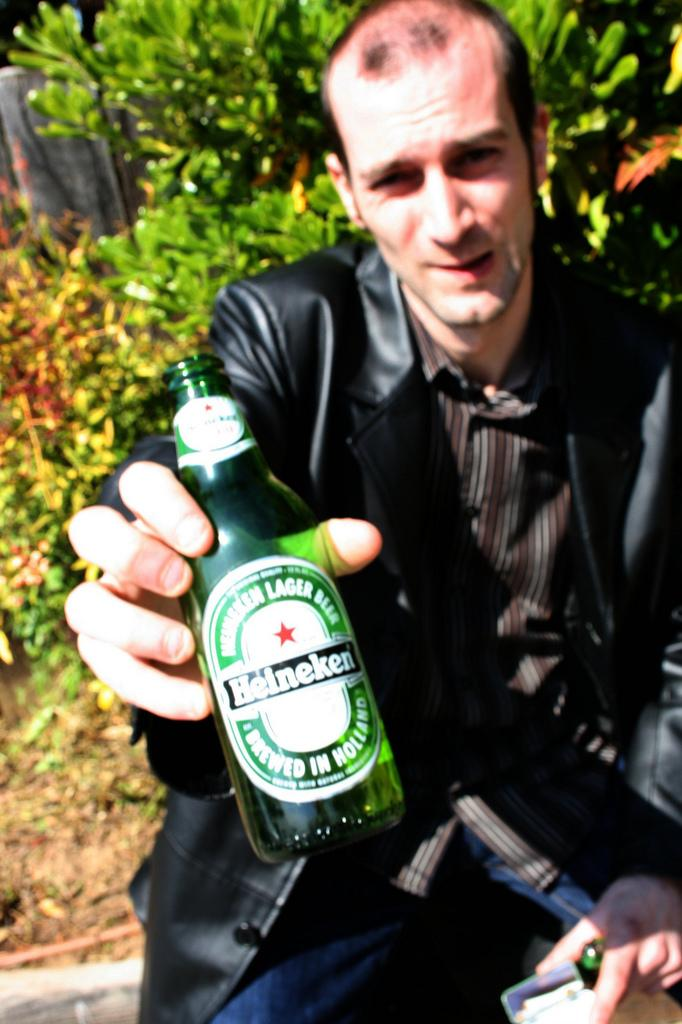Who is present in the image? There is a man in the image. What is the man holding in the image? The man is holding a green color bottle. What can be seen in the background of the image? There are trees in the background of the image. What type of scarf is the man wearing in the image? There is no scarf visible in the image; the man is holding a green color bottle. What does the image smell like? The image does not have a smell, as it is a visual representation. 